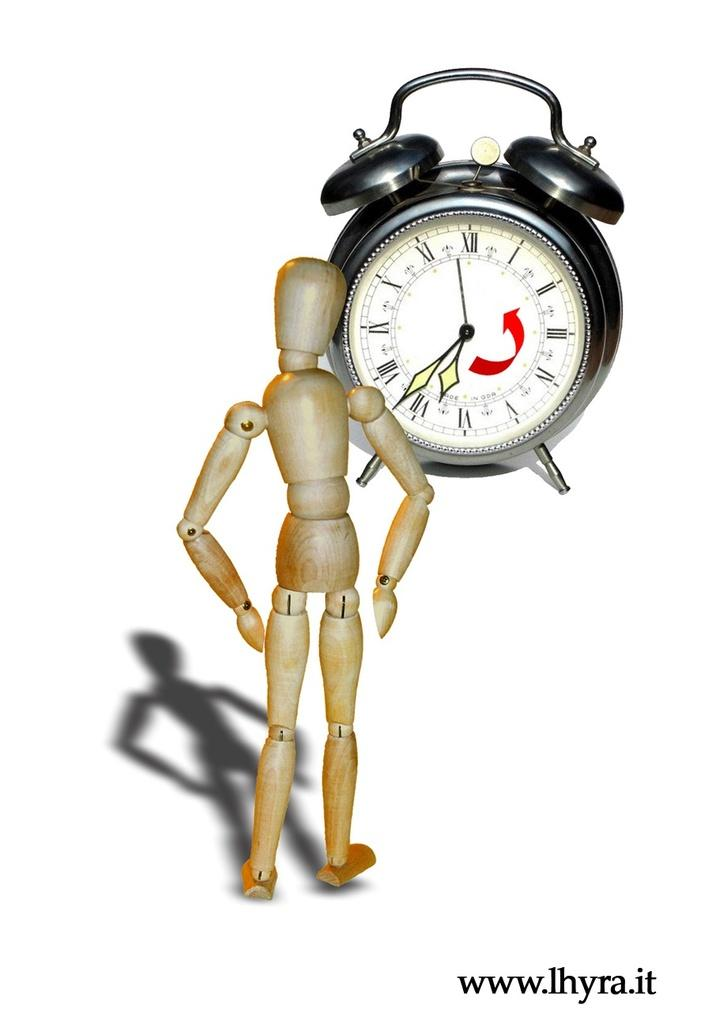<image>
Summarize the visual content of the image. A wooden doll staring at a clock that reads 6:37 